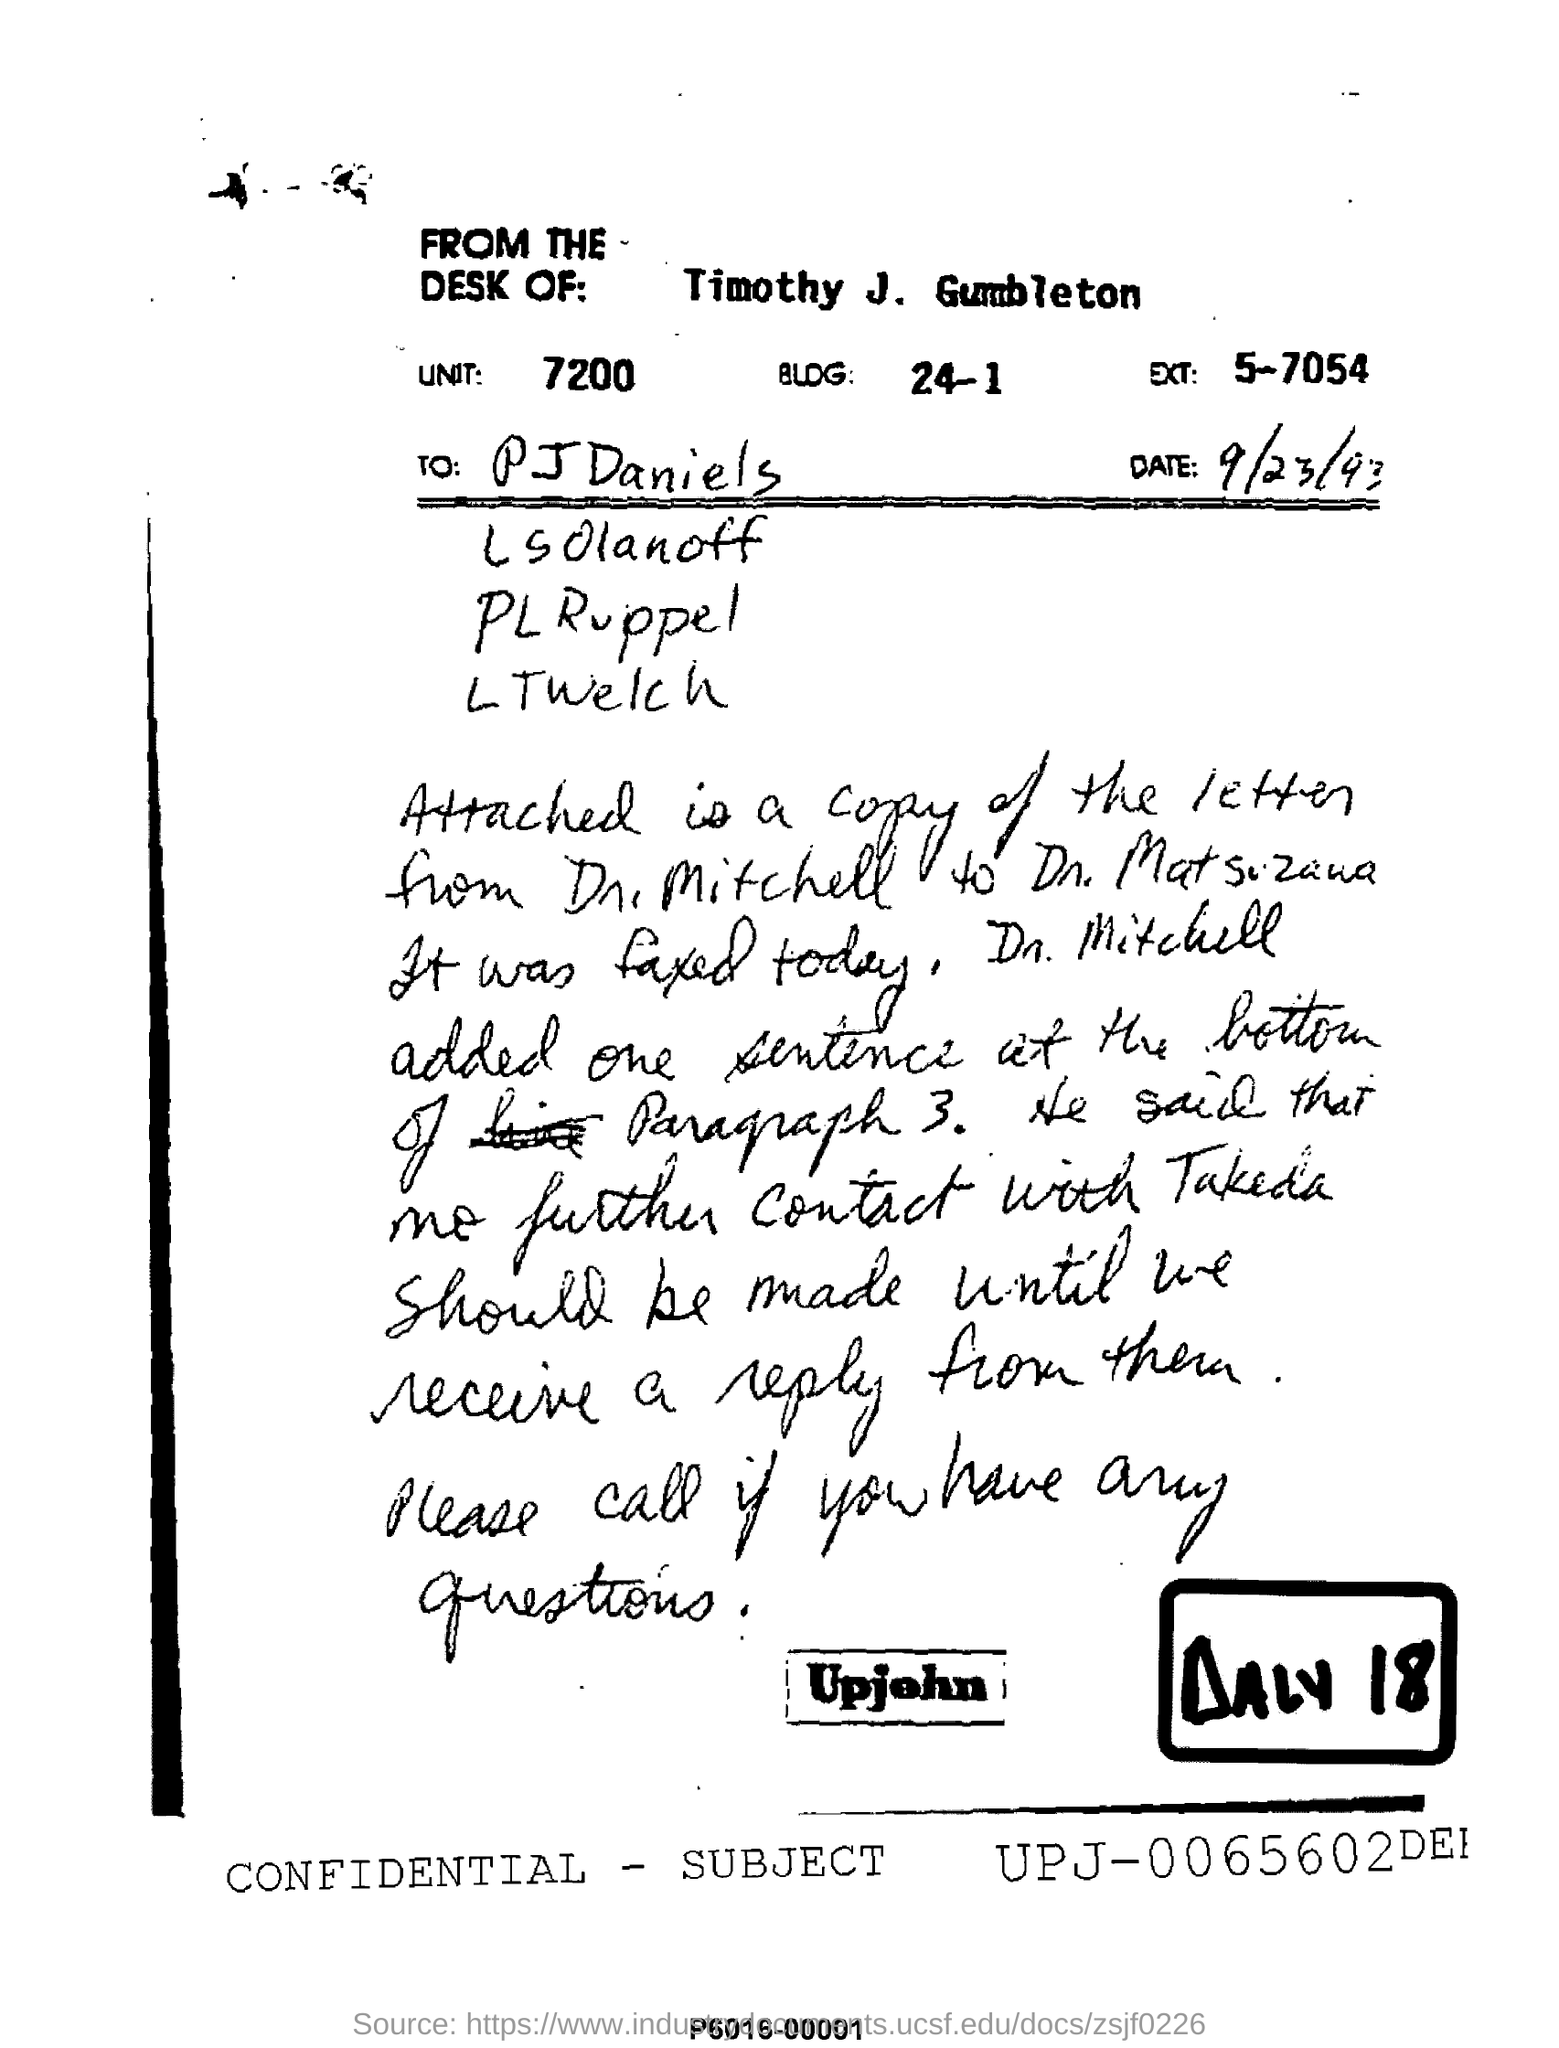Mention a couple of crucial points in this snapshot. The letter attached is copy of DR. Mitchell's. The unit mentioned in the letter is 7200.. The letter is written from the desk of Timothy J. Gumbleton. The email is addressed to "Name of the first person in the To list," with the name "PJ Daniels" written after it. The date mentioned is 9/23/93. 